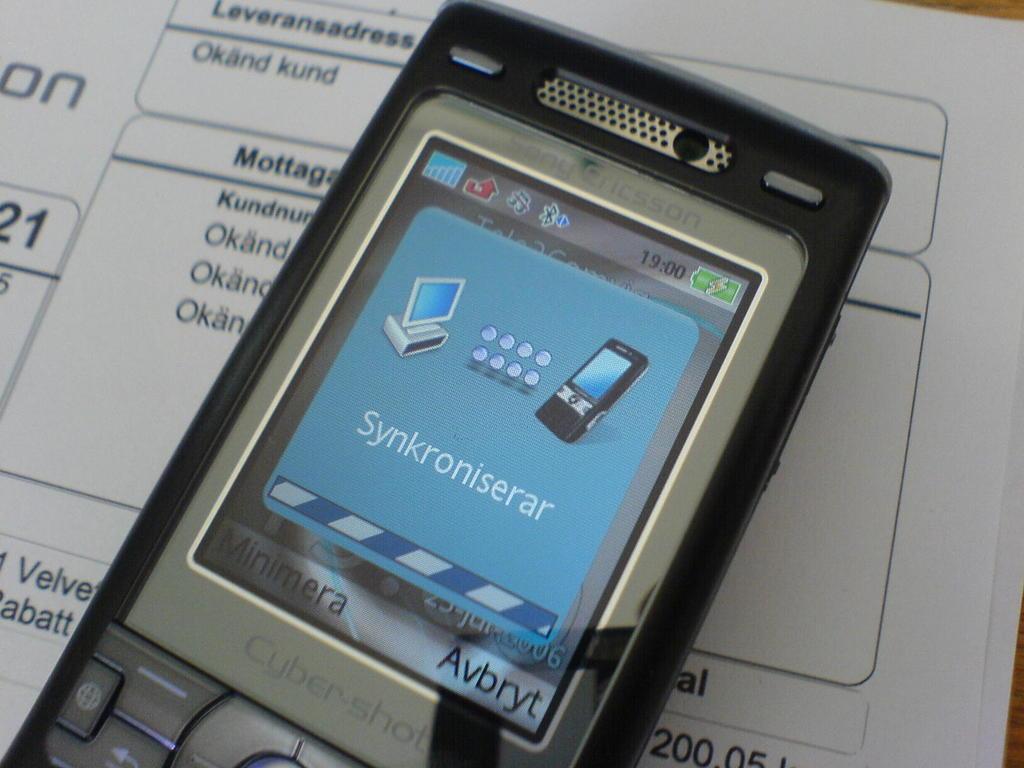What kind of phone is this?
Your answer should be very brief. Cybershot. What does the time on the phone say?
Your answer should be very brief. 19:00. 